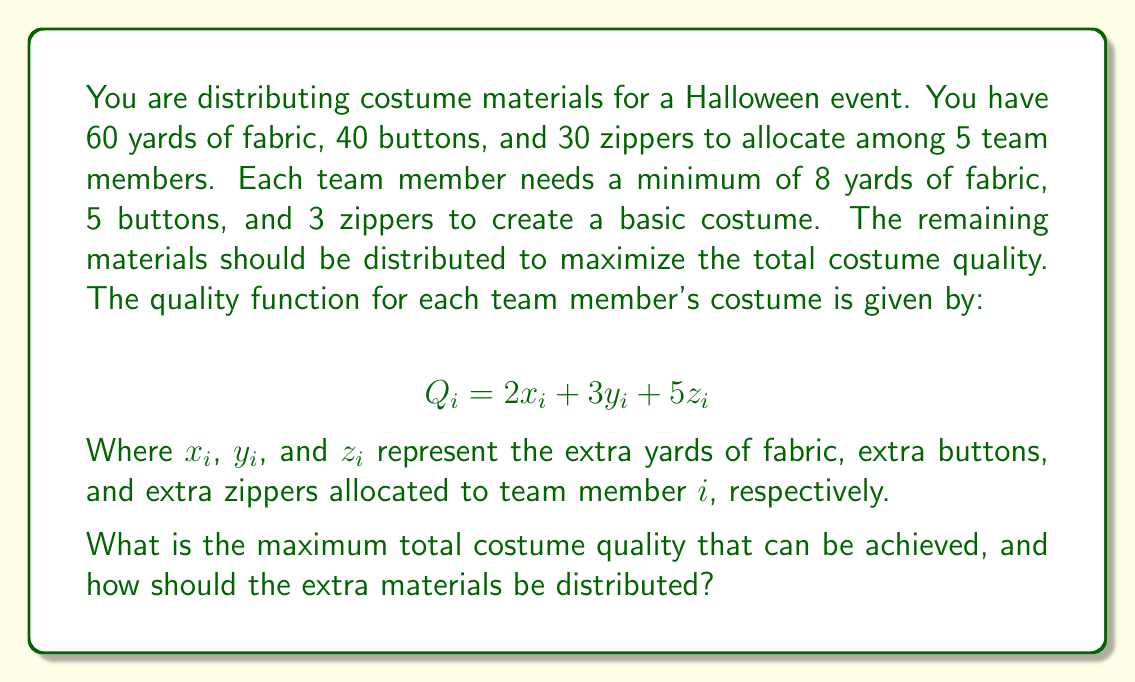What is the answer to this math problem? Let's approach this problem step-by-step:

1) First, calculate the minimum materials needed:
   Fabric: $5 \times 8 = 40$ yards
   Buttons: $5 \times 5 = 25$ buttons
   Zippers: $5 \times 3 = 15$ zippers

2) Calculate the extra materials available:
   Fabric: $60 - 40 = 20$ yards
   Buttons: $40 - 25 = 15$ buttons
   Zippers: $30 - 15 = 15$ zippers

3) Set up the optimization problem:
   Maximize: $\sum_{i=1}^5 Q_i = \sum_{i=1}^5 (2x_i + 3y_i + 5z_i)$
   Subject to:
   $$\sum_{i=1}^5 x_i \leq 20$$
   $$\sum_{i=1}^5 y_i \leq 15$$
   $$\sum_{i=1}^5 z_i \leq 15$$
   $$x_i, y_i, z_i \geq 0 \text{ for all } i$$

4) Observe that the coefficients in the quality function are different for each material. To maximize the total quality, we should allocate all extra materials to the item with the highest coefficient, which is zippers (coefficient 5).

5) Allocate all 15 extra zippers to one team member. This will yield a quality increase of:
   $15 \times 5 = 75$

6) The remaining materials (fabric and buttons) won't increase the quality further, so they can be distributed arbitrarily or kept as spares.

Therefore, the maximum total costume quality increase is 75, achieved by giving all 15 extra zippers to one team member and distributing the basic materials to everyone else.
Answer: The maximum total costume quality increase is 75. This is achieved by allocating all 15 extra zippers to one team member, while distributing only the basic materials to the other team members. The extra fabric (20 yards) and buttons (15) do not contribute to further quality increase and can be distributed arbitrarily or kept as spares. 